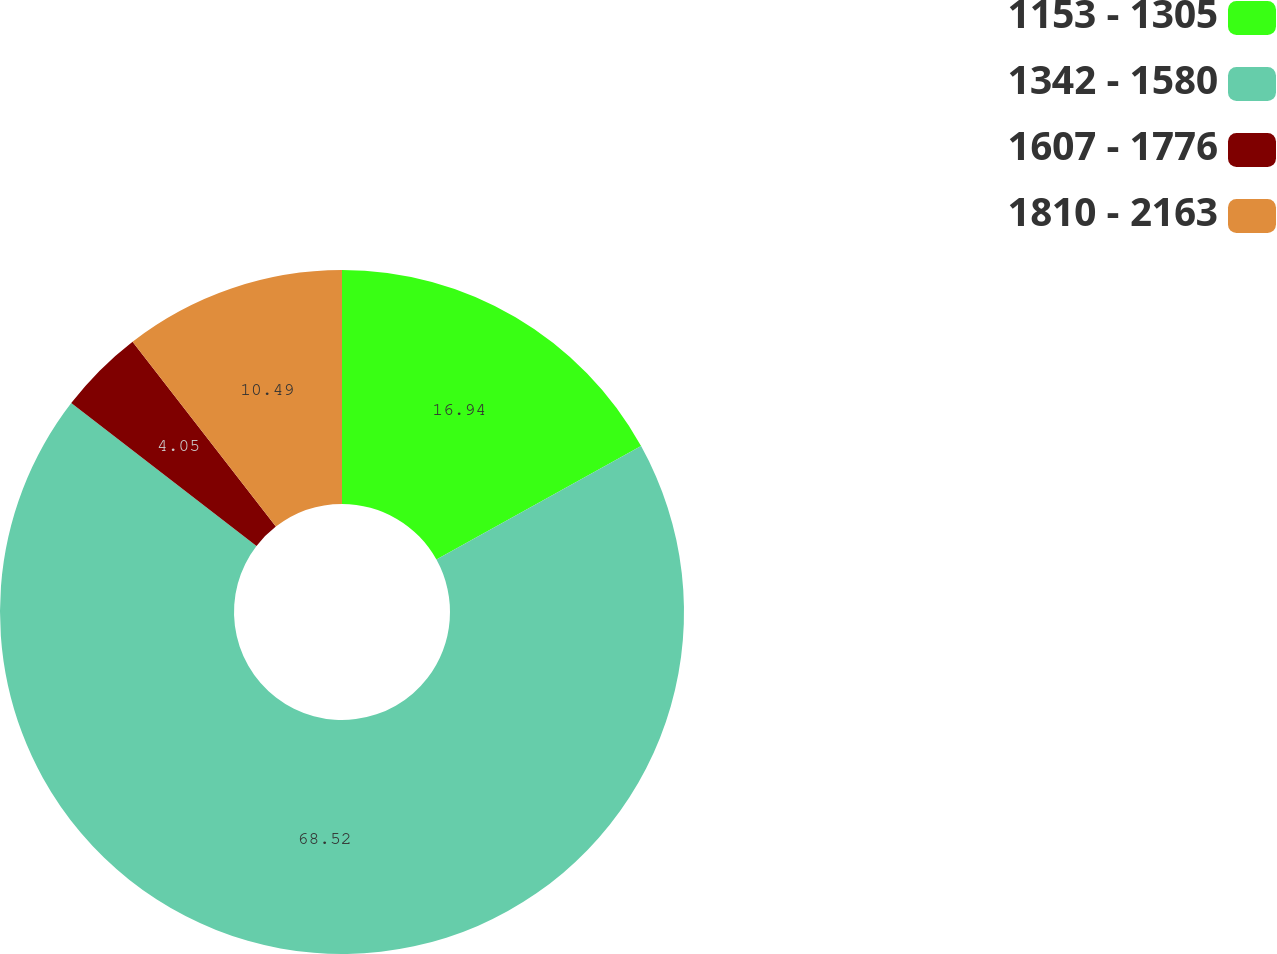Convert chart. <chart><loc_0><loc_0><loc_500><loc_500><pie_chart><fcel>1153 - 1305<fcel>1342 - 1580<fcel>1607 - 1776<fcel>1810 - 2163<nl><fcel>16.94%<fcel>68.52%<fcel>4.05%<fcel>10.49%<nl></chart> 